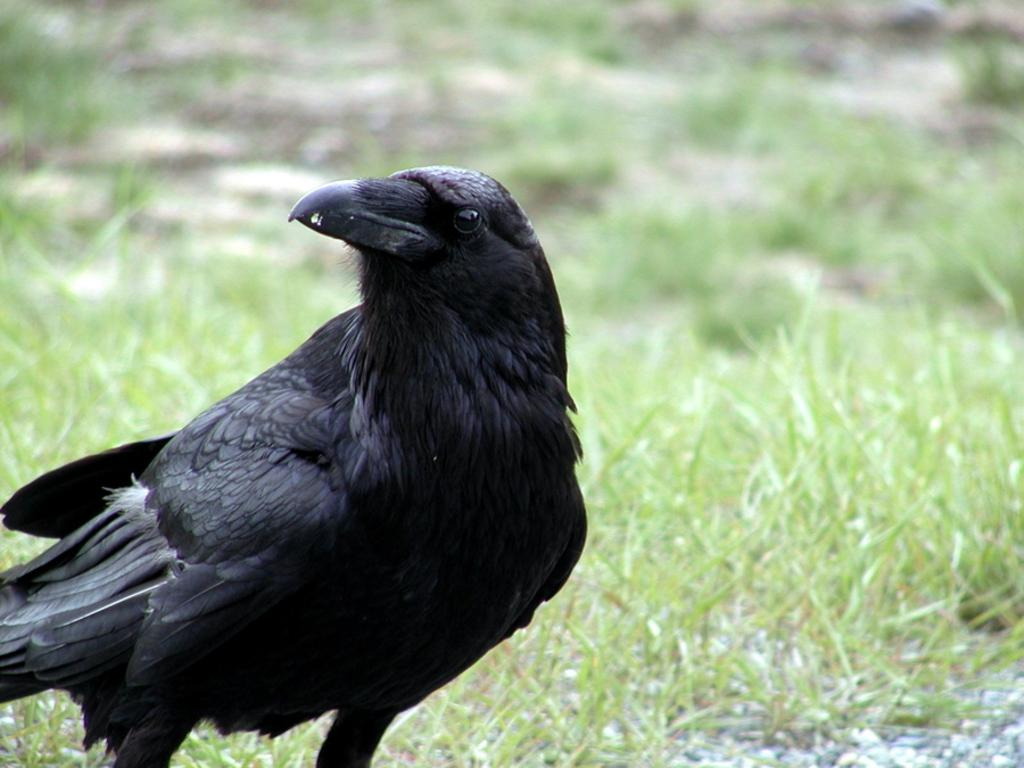What type of bird is in the picture? There is a crow in the picture. What color is the crow? The crow is black in color. What can be seen in the background of the picture? There is grass in the background of the picture. How is the grass depicted in the image? The grass is blurred in the background. How many dolls are sitting on the crow's back in the image? There are no dolls present in the image, and the crow's back is not visible. What type of maid is attending to the crow in the image? There is no maid present in the image, and the crow is not interacting with any person. 